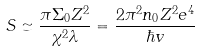Convert formula to latex. <formula><loc_0><loc_0><loc_500><loc_500>S \simeq \frac { \pi \Sigma _ { 0 } Z ^ { 2 } } { \chi ^ { 2 } \lambda } = \frac { 2 \pi ^ { 2 } n _ { 0 } Z ^ { 2 } e ^ { 4 } } { \hbar { v } }</formula> 